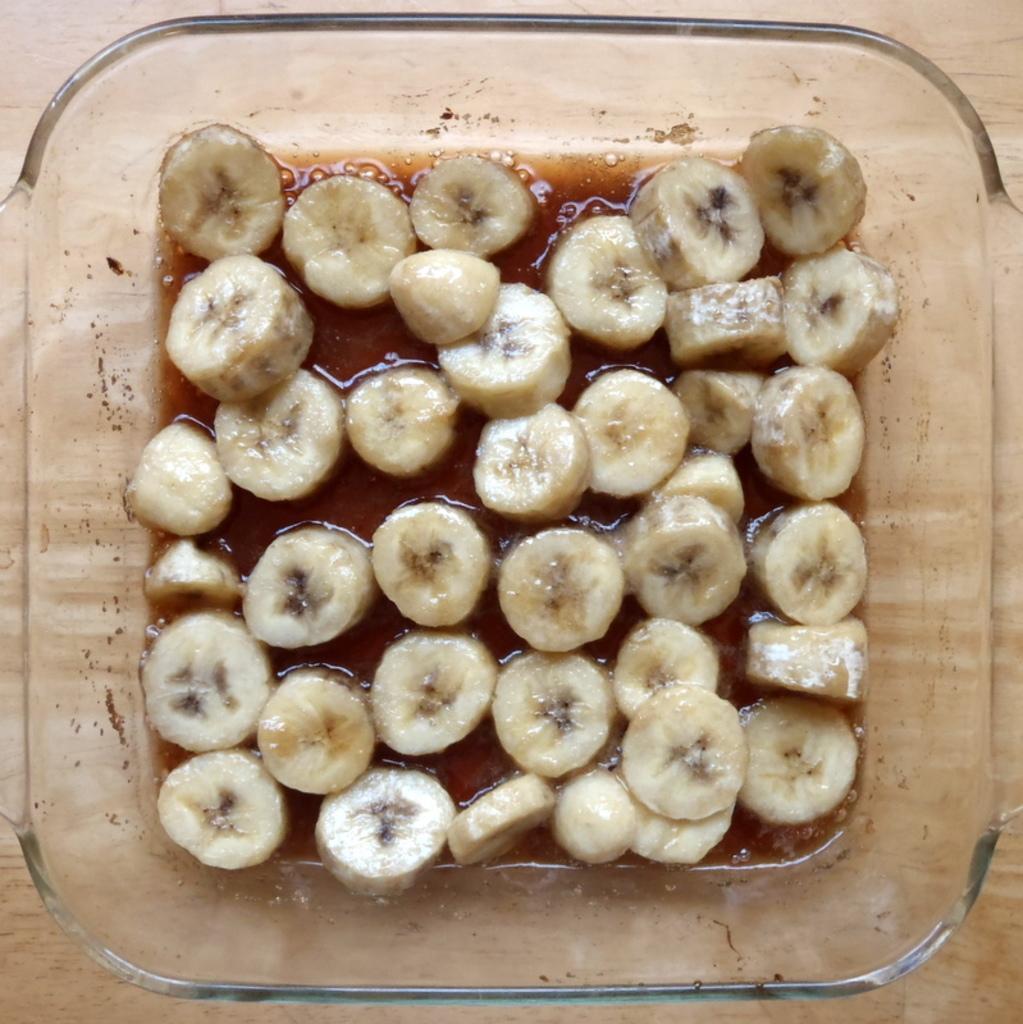Can you describe this image briefly? In this image I can see bananas and other food items in a glass bowl. This bowl is on a wooden surface. 